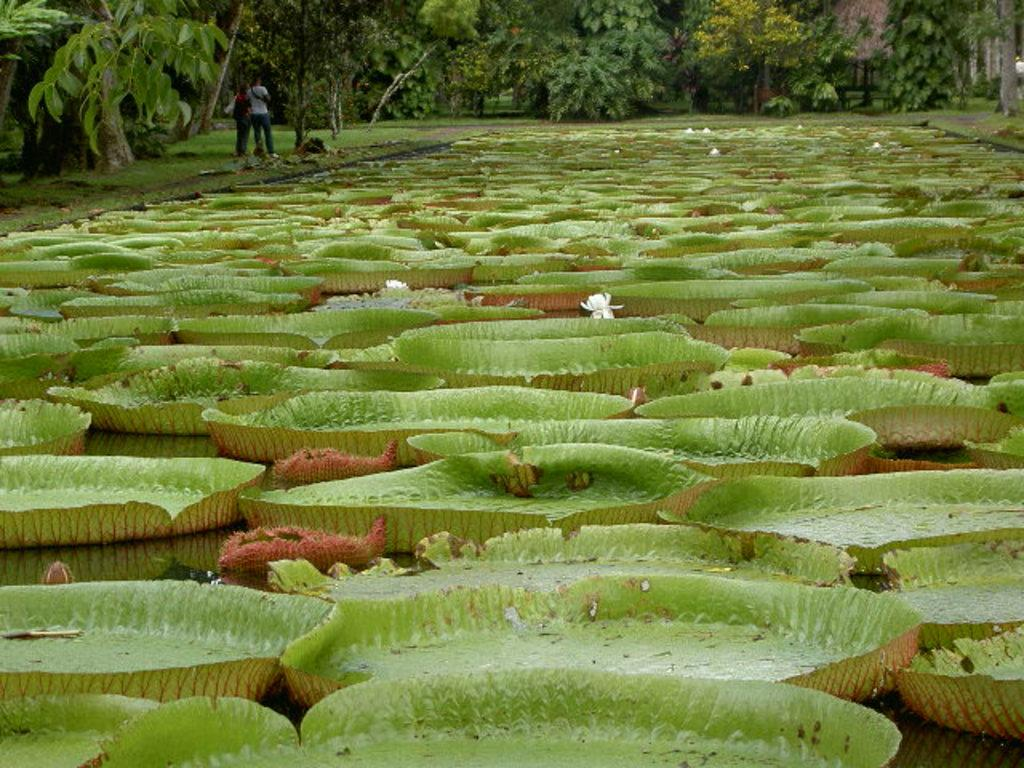What is floating in the water in the image? There are leaves and flowers in the water. Can you describe the people in the image? There are people standing in the image. What type of vegetation is visible in the image? There are trees visible in the image. What type of maid can be seen cleaning the aftermath of a wave in the image? There is no maid or wave present in the image. What type of wave can be seen crashing into the trees in the image? There is no wave present in the image; it features leaves and flowers in the water, people standing, and trees. 